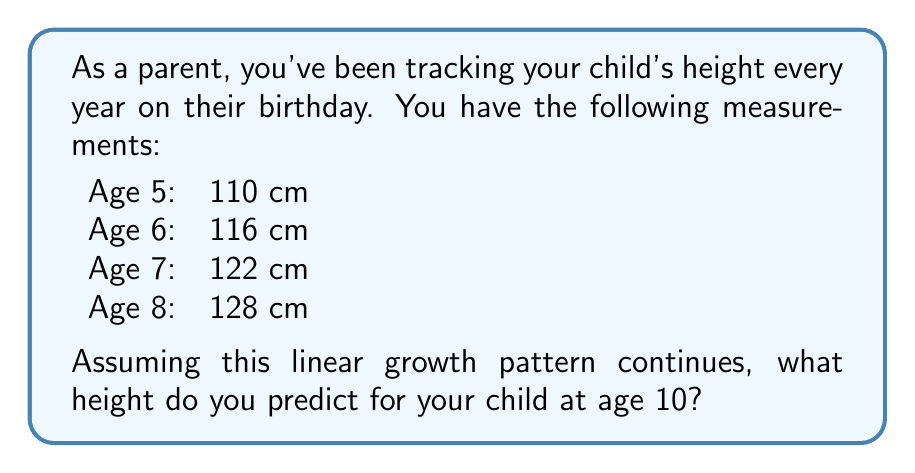Solve this math problem. To solve this problem, we'll use a simple linear regression model, which is a common technique in time series analysis for predicting future values based on historical data.

Step 1: Identify the pattern
Looking at the given data, we can see that the child's height increases by 6 cm each year. This suggests a linear growth pattern.

Step 2: Express the relationship mathematically
We can express the child's height (H) as a function of their age (A) using the equation:

$$ H = mA + b $$

Where:
$m$ is the slope (annual growth rate)
$b$ is the y-intercept (theoretical height at age 0)

Step 3: Calculate the slope (m)
The slope represents the annual growth rate:

$$ m = \frac{\text{change in height}}{\text{change in age}} = \frac{128 - 110}{8 - 5} = \frac{18}{3} = 6 \text{ cm/year} $$

Step 4: Find the y-intercept (b)
We can use any point to find b. Let's use the age 5 data point:

$$ 110 = 6(5) + b $$
$$ 110 = 30 + b $$
$$ b = 80 $$

Step 5: Write the complete equation
$$ H = 6A + 80 $$

Step 6: Predict the height at age 10
Now we can plug in A = 10 to predict the height at age 10:

$$ H = 6(10) + 80 = 60 + 80 = 140 $$

Therefore, we predict the child's height at age 10 to be 140 cm.
Answer: 140 cm 